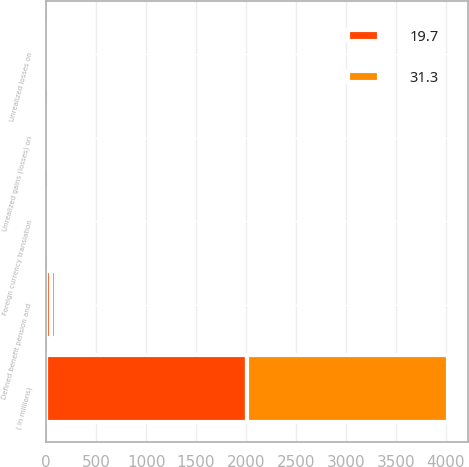Convert chart. <chart><loc_0><loc_0><loc_500><loc_500><stacked_bar_chart><ecel><fcel>( in millions)<fcel>Foreign currency translation<fcel>Unrealized gains (losses) on<fcel>Unrealized losses on<fcel>Defined benefit pension and<nl><fcel>31.3<fcel>2010<fcel>22<fcel>0.1<fcel>3.7<fcel>49.7<nl><fcel>19.7<fcel>2009<fcel>35<fcel>0.5<fcel>3.4<fcel>50.8<nl></chart> 